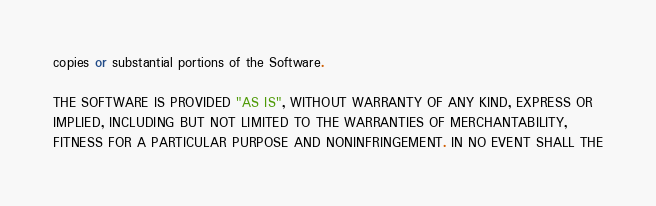Convert code to text. <code><loc_0><loc_0><loc_500><loc_500><_Python_>copies or substantial portions of the Software.

THE SOFTWARE IS PROVIDED "AS IS", WITHOUT WARRANTY OF ANY KIND, EXPRESS OR
IMPLIED, INCLUDING BUT NOT LIMITED TO THE WARRANTIES OF MERCHANTABILITY,
FITNESS FOR A PARTICULAR PURPOSE AND NONINFRINGEMENT. IN NO EVENT SHALL THE</code> 